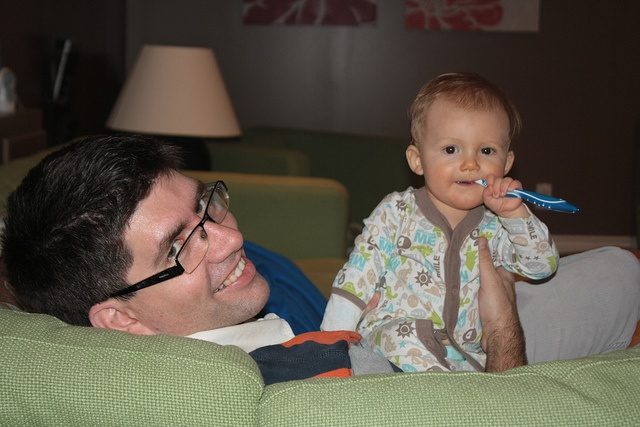Describe the objects in this image and their specific colors. I can see people in black, gray, and salmon tones, couch in black, olive, darkgray, and gray tones, people in black, darkgray, gray, and tan tones, and toothbrush in black, blue, darkblue, and gray tones in this image. 